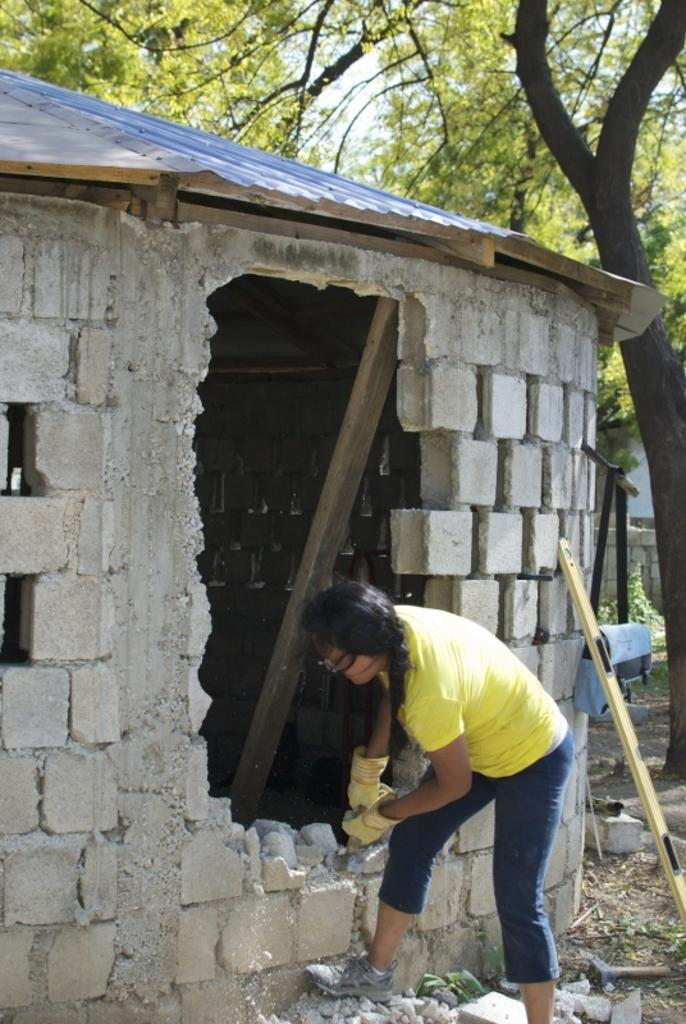Who is the main subject in the image? There is a woman in the image. What is the woman doing in the image? The woman is constructing a wall with a brick. What is the woman wearing in the image? The woman is wearing a yellow T-shirt and gloves. What can be seen in the background of the image? There is a tree in the background of the image. How many birds are sitting on the woman's shoulder in the image? There are no birds present in the image. Is the woman attempting to burn the brick in the image? There is no indication in the image that the woman is trying to burn the brick; she is constructing a wall with it. 